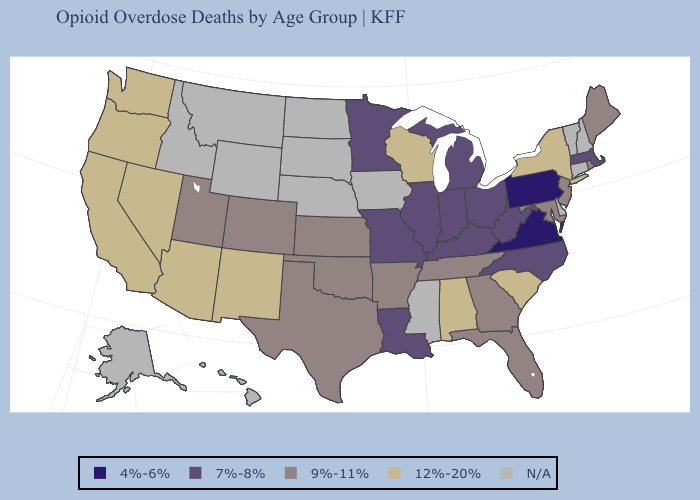What is the value of New Jersey?
Give a very brief answer. 9%-11%. Does New York have the highest value in the Northeast?
Keep it brief. Yes. Name the states that have a value in the range 12%-20%?
Quick response, please. Alabama, Arizona, California, Nevada, New Mexico, New York, Oregon, South Carolina, Washington, Wisconsin. What is the value of South Dakota?
Short answer required. N/A. What is the lowest value in states that border Idaho?
Give a very brief answer. 9%-11%. Among the states that border Nebraska , which have the lowest value?
Concise answer only. Missouri. Does Virginia have the lowest value in the USA?
Write a very short answer. Yes. Does Arkansas have the lowest value in the USA?
Give a very brief answer. No. What is the value of New York?
Concise answer only. 12%-20%. What is the lowest value in states that border New Mexico?
Quick response, please. 9%-11%. Among the states that border Maryland , does West Virginia have the highest value?
Write a very short answer. Yes. What is the value of Wisconsin?
Concise answer only. 12%-20%. Is the legend a continuous bar?
Answer briefly. No. Name the states that have a value in the range 9%-11%?
Short answer required. Arkansas, Colorado, Florida, Georgia, Kansas, Maine, Maryland, New Jersey, Oklahoma, Rhode Island, Tennessee, Texas, Utah. Among the states that border Washington , which have the lowest value?
Short answer required. Oregon. 